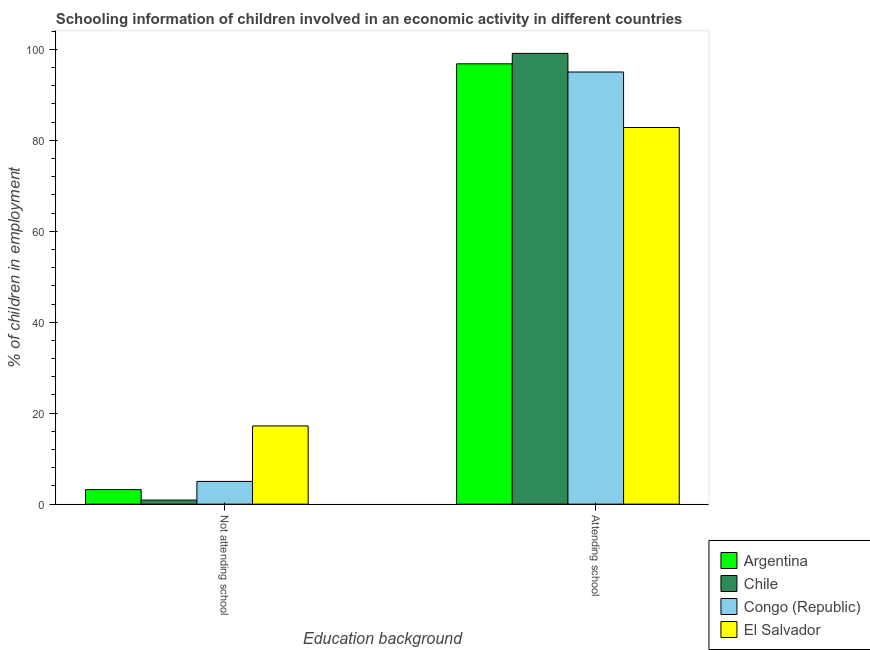Are the number of bars per tick equal to the number of legend labels?
Provide a short and direct response. Yes. How many bars are there on the 2nd tick from the right?
Provide a succinct answer. 4. What is the label of the 1st group of bars from the left?
Keep it short and to the point. Not attending school. What is the percentage of employed children who are attending school in Argentina?
Give a very brief answer. 96.8. Across all countries, what is the maximum percentage of employed children who are not attending school?
Provide a succinct answer. 17.2. Across all countries, what is the minimum percentage of employed children who are attending school?
Provide a succinct answer. 82.8. In which country was the percentage of employed children who are not attending school maximum?
Offer a terse response. El Salvador. What is the total percentage of employed children who are attending school in the graph?
Keep it short and to the point. 373.7. What is the difference between the percentage of employed children who are attending school in Chile and that in Congo (Republic)?
Your answer should be compact. 4.1. What is the difference between the percentage of employed children who are not attending school in El Salvador and the percentage of employed children who are attending school in Chile?
Give a very brief answer. -81.9. What is the average percentage of employed children who are attending school per country?
Offer a terse response. 93.42. What is the difference between the percentage of employed children who are attending school and percentage of employed children who are not attending school in Argentina?
Ensure brevity in your answer.  93.6. What is the ratio of the percentage of employed children who are not attending school in Chile to that in Congo (Republic)?
Offer a very short reply. 0.18. What does the 3rd bar from the left in Attending school represents?
Make the answer very short. Congo (Republic). What does the 1st bar from the right in Not attending school represents?
Your response must be concise. El Salvador. How many bars are there?
Your answer should be compact. 8. What is the difference between two consecutive major ticks on the Y-axis?
Your answer should be very brief. 20. Are the values on the major ticks of Y-axis written in scientific E-notation?
Offer a very short reply. No. Where does the legend appear in the graph?
Give a very brief answer. Bottom right. What is the title of the graph?
Give a very brief answer. Schooling information of children involved in an economic activity in different countries. Does "Bahrain" appear as one of the legend labels in the graph?
Your answer should be very brief. No. What is the label or title of the X-axis?
Your response must be concise. Education background. What is the label or title of the Y-axis?
Provide a succinct answer. % of children in employment. What is the % of children in employment in Argentina in Not attending school?
Provide a short and direct response. 3.2. What is the % of children in employment of El Salvador in Not attending school?
Give a very brief answer. 17.2. What is the % of children in employment in Argentina in Attending school?
Give a very brief answer. 96.8. What is the % of children in employment in Chile in Attending school?
Provide a short and direct response. 99.1. What is the % of children in employment in El Salvador in Attending school?
Make the answer very short. 82.8. Across all Education background, what is the maximum % of children in employment of Argentina?
Provide a succinct answer. 96.8. Across all Education background, what is the maximum % of children in employment of Chile?
Your response must be concise. 99.1. Across all Education background, what is the maximum % of children in employment of Congo (Republic)?
Make the answer very short. 95. Across all Education background, what is the maximum % of children in employment of El Salvador?
Offer a terse response. 82.8. Across all Education background, what is the minimum % of children in employment in Congo (Republic)?
Provide a short and direct response. 5. What is the total % of children in employment in Chile in the graph?
Offer a very short reply. 100. What is the difference between the % of children in employment of Argentina in Not attending school and that in Attending school?
Provide a short and direct response. -93.6. What is the difference between the % of children in employment of Chile in Not attending school and that in Attending school?
Give a very brief answer. -98.2. What is the difference between the % of children in employment of Congo (Republic) in Not attending school and that in Attending school?
Ensure brevity in your answer.  -90. What is the difference between the % of children in employment of El Salvador in Not attending school and that in Attending school?
Your answer should be very brief. -65.6. What is the difference between the % of children in employment in Argentina in Not attending school and the % of children in employment in Chile in Attending school?
Make the answer very short. -95.9. What is the difference between the % of children in employment in Argentina in Not attending school and the % of children in employment in Congo (Republic) in Attending school?
Provide a short and direct response. -91.8. What is the difference between the % of children in employment of Argentina in Not attending school and the % of children in employment of El Salvador in Attending school?
Ensure brevity in your answer.  -79.6. What is the difference between the % of children in employment of Chile in Not attending school and the % of children in employment of Congo (Republic) in Attending school?
Your response must be concise. -94.1. What is the difference between the % of children in employment of Chile in Not attending school and the % of children in employment of El Salvador in Attending school?
Your answer should be compact. -81.9. What is the difference between the % of children in employment of Congo (Republic) in Not attending school and the % of children in employment of El Salvador in Attending school?
Give a very brief answer. -77.8. What is the average % of children in employment in Chile per Education background?
Your response must be concise. 50. What is the difference between the % of children in employment in Argentina and % of children in employment in Congo (Republic) in Not attending school?
Give a very brief answer. -1.8. What is the difference between the % of children in employment in Chile and % of children in employment in Congo (Republic) in Not attending school?
Offer a very short reply. -4.1. What is the difference between the % of children in employment in Chile and % of children in employment in El Salvador in Not attending school?
Provide a succinct answer. -16.3. What is the difference between the % of children in employment of Argentina and % of children in employment of El Salvador in Attending school?
Your answer should be compact. 14. What is the difference between the % of children in employment in Chile and % of children in employment in Congo (Republic) in Attending school?
Your answer should be compact. 4.1. What is the difference between the % of children in employment of Congo (Republic) and % of children in employment of El Salvador in Attending school?
Keep it short and to the point. 12.2. What is the ratio of the % of children in employment in Argentina in Not attending school to that in Attending school?
Provide a short and direct response. 0.03. What is the ratio of the % of children in employment in Chile in Not attending school to that in Attending school?
Provide a succinct answer. 0.01. What is the ratio of the % of children in employment in Congo (Republic) in Not attending school to that in Attending school?
Keep it short and to the point. 0.05. What is the ratio of the % of children in employment in El Salvador in Not attending school to that in Attending school?
Offer a terse response. 0.21. What is the difference between the highest and the second highest % of children in employment in Argentina?
Your response must be concise. 93.6. What is the difference between the highest and the second highest % of children in employment of Chile?
Make the answer very short. 98.2. What is the difference between the highest and the second highest % of children in employment of Congo (Republic)?
Ensure brevity in your answer.  90. What is the difference between the highest and the second highest % of children in employment in El Salvador?
Provide a succinct answer. 65.6. What is the difference between the highest and the lowest % of children in employment in Argentina?
Provide a short and direct response. 93.6. What is the difference between the highest and the lowest % of children in employment in Chile?
Ensure brevity in your answer.  98.2. What is the difference between the highest and the lowest % of children in employment in El Salvador?
Provide a short and direct response. 65.6. 